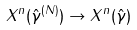<formula> <loc_0><loc_0><loc_500><loc_500>X ^ { n } ( \hat { \gamma } ^ { ( N ) } ) \rightarrow X ^ { n } ( \hat { \gamma } )</formula> 